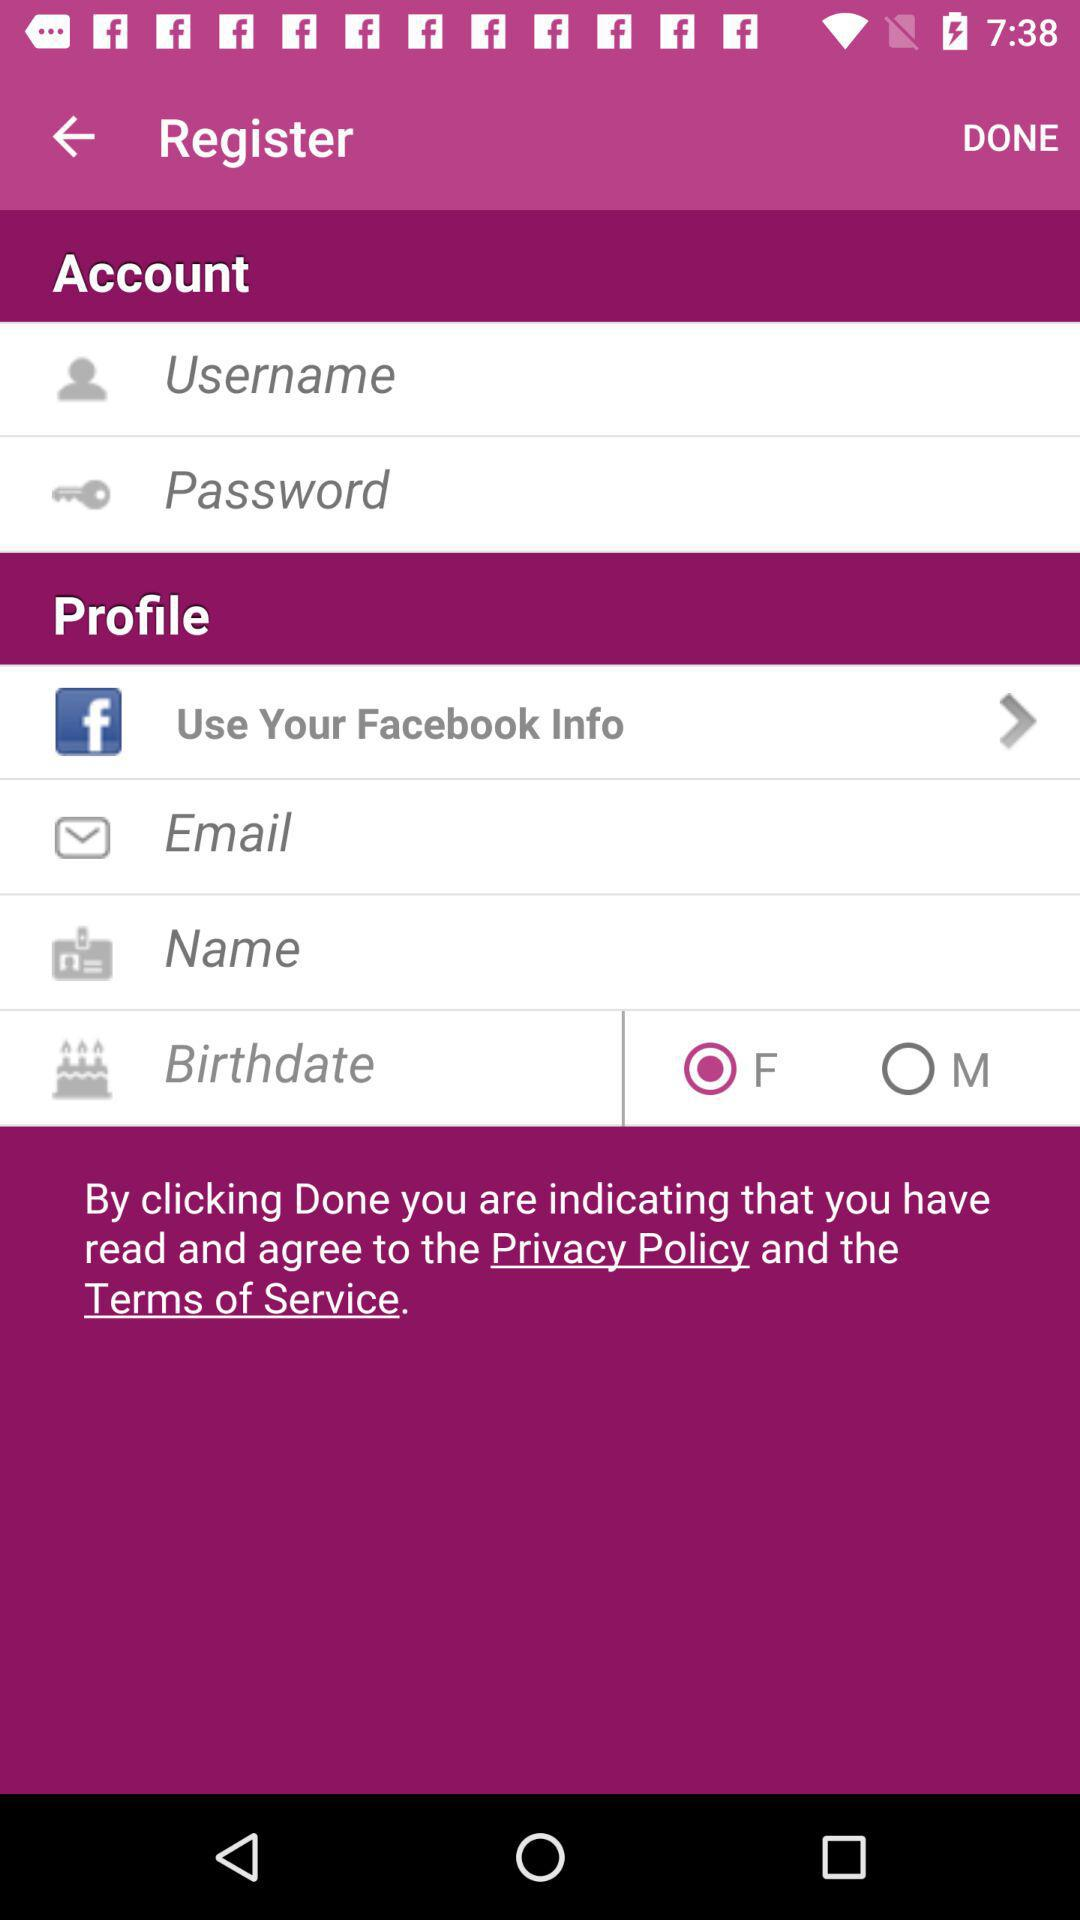What application helps in providing information for registration? The application is "Facebook". 